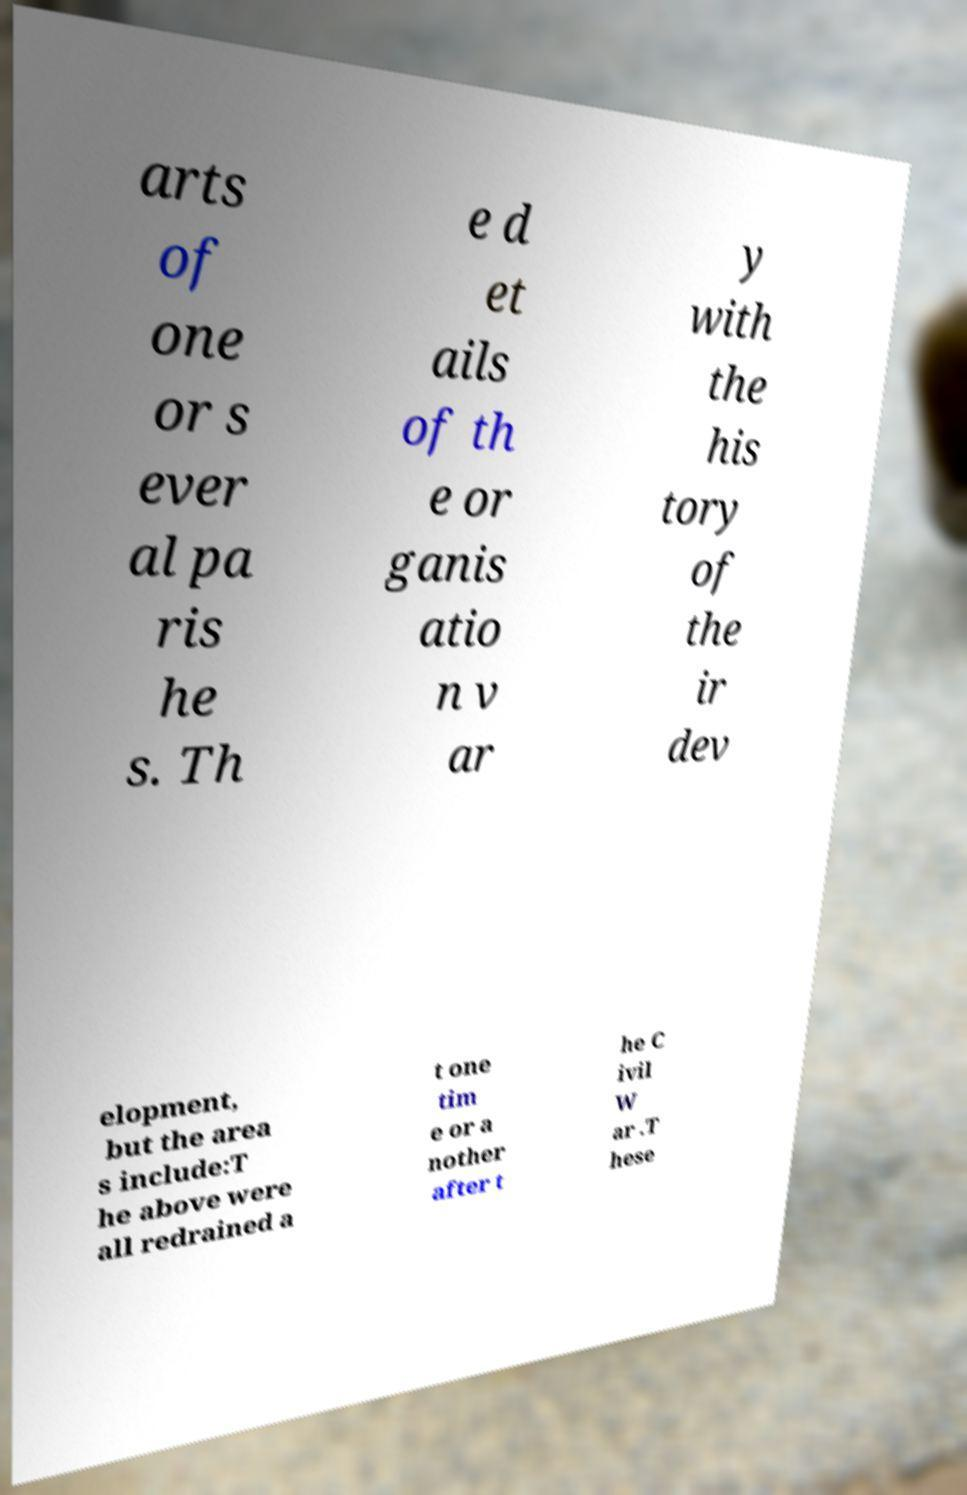Could you extract and type out the text from this image? arts of one or s ever al pa ris he s. Th e d et ails of th e or ganis atio n v ar y with the his tory of the ir dev elopment, but the area s include:T he above were all redrained a t one tim e or a nother after t he C ivil W ar .T hese 